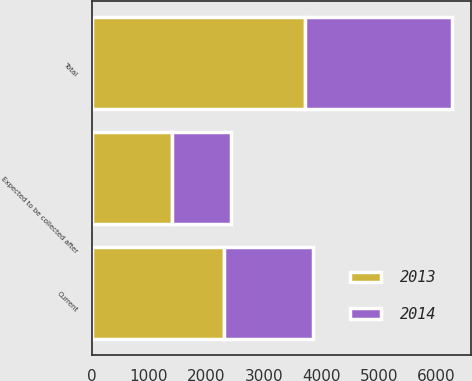<chart> <loc_0><loc_0><loc_500><loc_500><stacked_bar_chart><ecel><fcel>Current<fcel>Expected to be collected after<fcel>Total<nl><fcel>2013<fcel>2306<fcel>1408<fcel>3714<nl><fcel>2014<fcel>1550<fcel>1020<fcel>2570<nl></chart> 